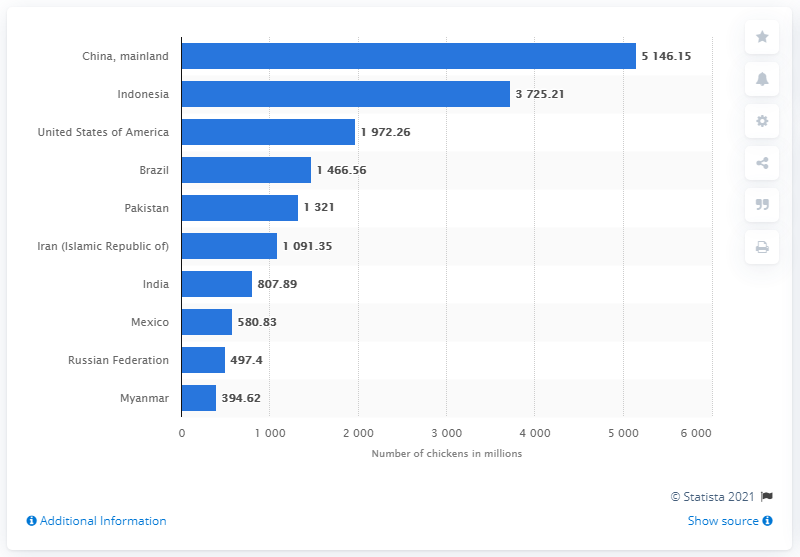Point out several critical features in this image. In 2019, it is estimated that there were approximately 51,461.5 chickens living in China. 